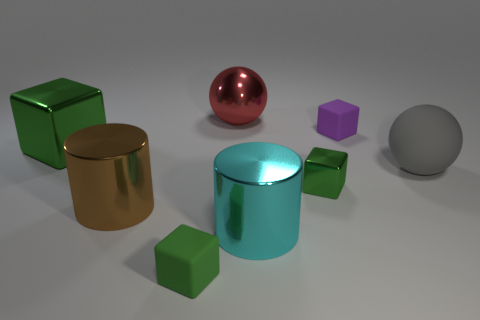Subtract all red balls. How many green cubes are left? 3 Add 2 cyan rubber blocks. How many objects exist? 10 Subtract all spheres. How many objects are left? 6 Add 1 metal blocks. How many metal blocks exist? 3 Subtract 0 yellow blocks. How many objects are left? 8 Subtract all large yellow objects. Subtract all gray spheres. How many objects are left? 7 Add 3 big red metallic balls. How many big red metallic balls are left? 4 